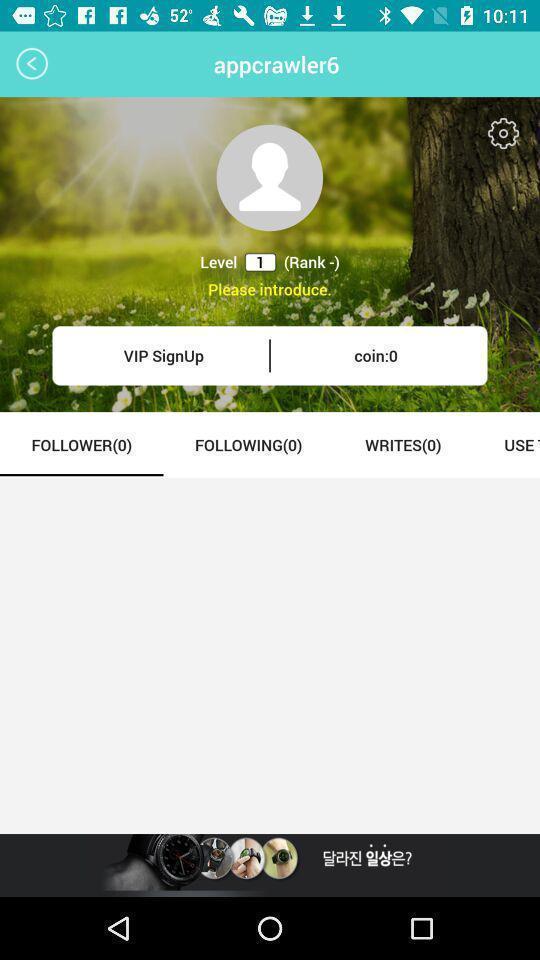Summarize the information in this screenshot. Profile page. 